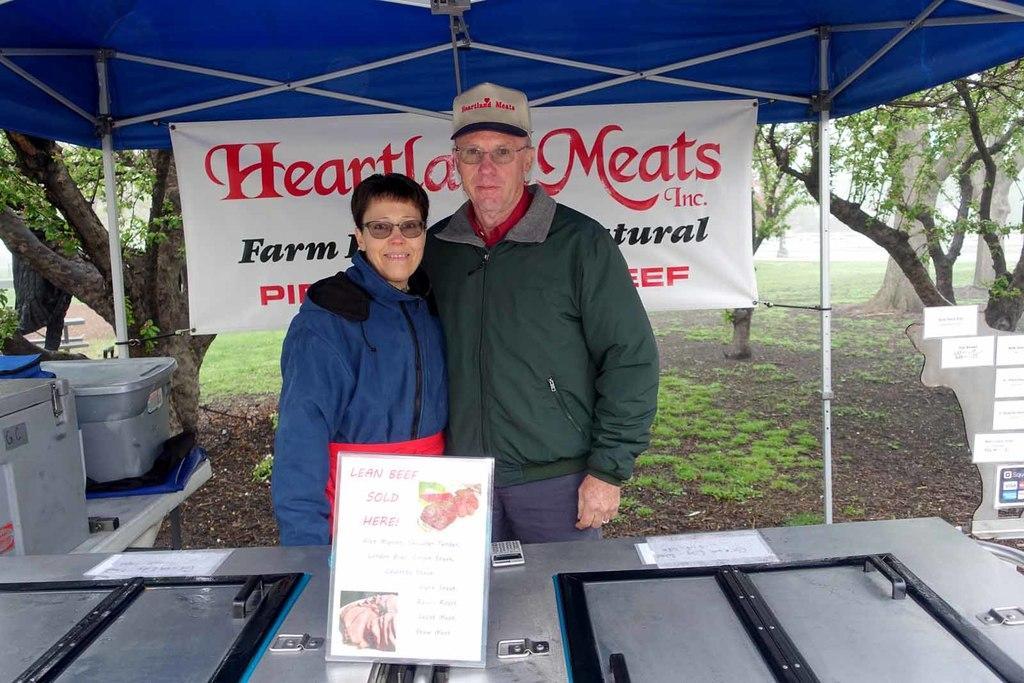In one or two sentences, can you explain what this image depicts? In the foreground of the image we can see a board with some pictures and text placed on a surface containing a door and a device on it. In the center of the image we can see two persons wearing spectacles. To the left side of the image we can see containers placed on the table. In the background, we can see a banner with some text, tent and group of trees. 